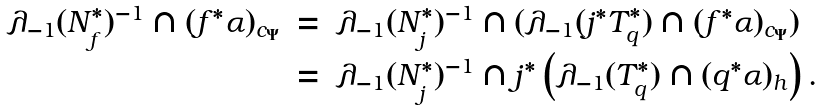<formula> <loc_0><loc_0><loc_500><loc_500>\begin{array} { r c l } \lambda _ { - 1 } ( N _ { f } ^ { * } ) ^ { - 1 } \cap ( f ^ { * } \alpha ) _ { c _ { \Psi } } & = & \lambda _ { - 1 } ( N _ { j } ^ { * } ) ^ { - 1 } \cap ( \lambda _ { - 1 } ( j ^ { * } T _ { q } ^ { * } ) \cap ( f ^ { * } \alpha ) _ { c _ { \Psi } } ) \\ & = & \lambda _ { - 1 } ( N _ { j } ^ { * } ) ^ { - 1 } \cap j ^ { * } \left ( \lambda _ { - 1 } ( T _ { q } ^ { * } ) \cap ( q ^ { * } \alpha ) _ { h } \right ) . \end{array}</formula> 